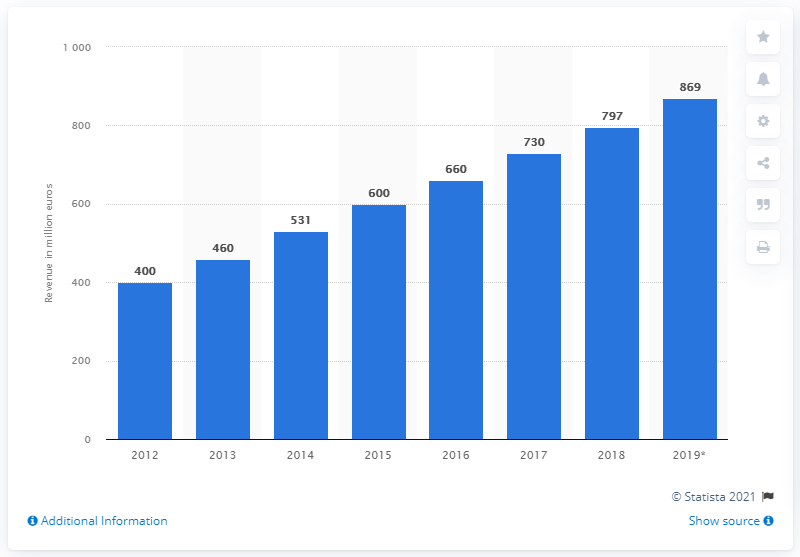Indicate a few pertinent items in this graphic. The retail e-commerce market was forecasted to reach a value of 869 in 2019. In 2018, the value of online sales in Luxembourg was approximately 797 million euros. 